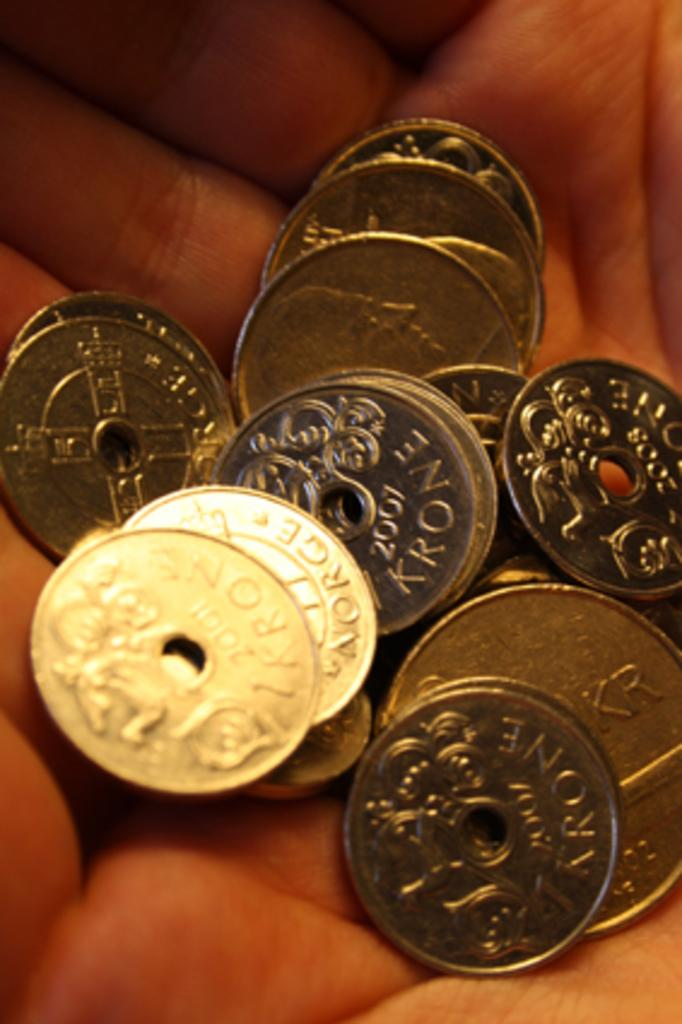What objects are being held by the person in the image? There are coins in the person's hands in the image. What might the person be about to do with the coins? The person might be about to deposit the coins, exchange them for something, or save them. Can you describe the person's hands in the image? The person's hands are holding the coins, and their fingers are visible. What type of food is being prepared in the image? There is no food present in the image; it only shows coins in a person's hands. 